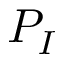Convert formula to latex. <formula><loc_0><loc_0><loc_500><loc_500>P _ { I }</formula> 